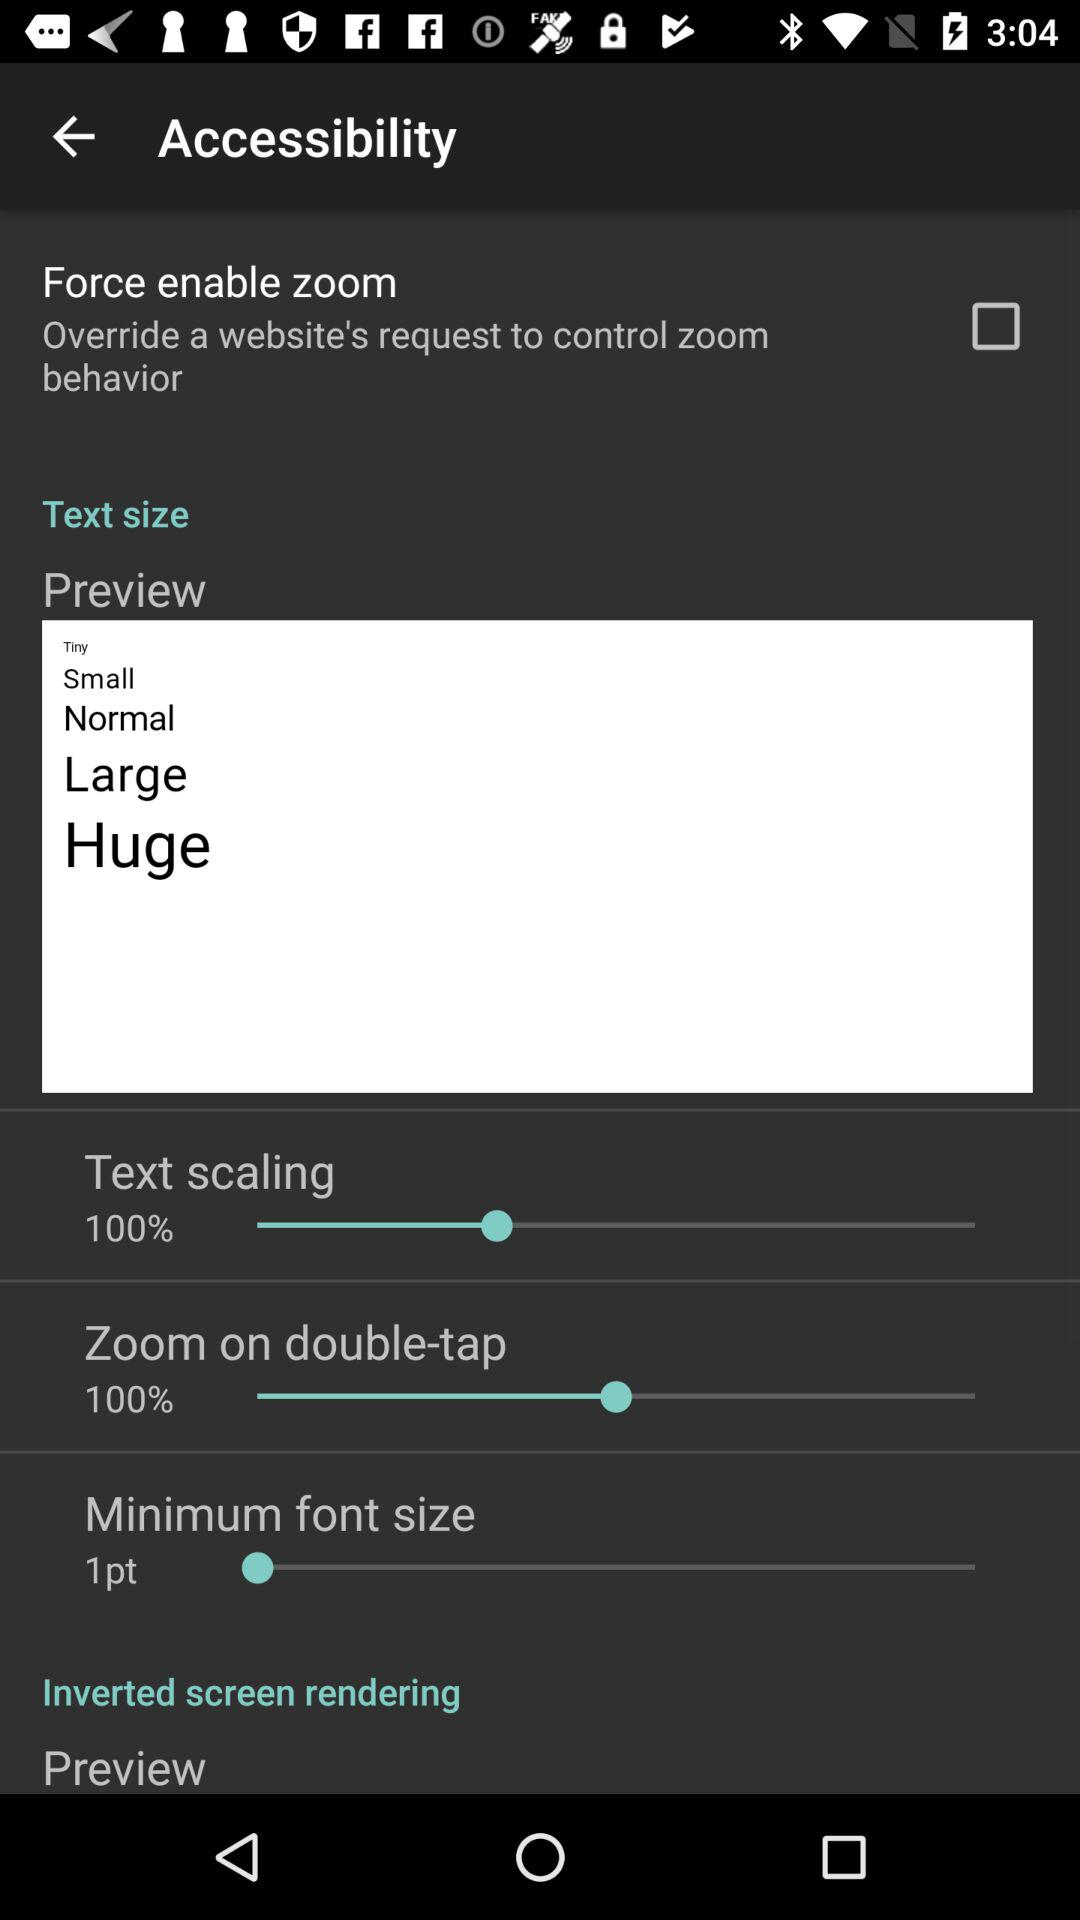What is the text scaling size? The text scaling size is 100%. 